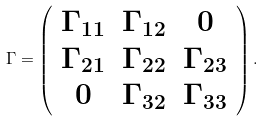<formula> <loc_0><loc_0><loc_500><loc_500>\Gamma = \left ( \begin{array} { c c c } \Gamma _ { 1 1 } & \Gamma _ { 1 2 } & 0 \\ \Gamma _ { 2 1 } & \Gamma _ { 2 2 } & \Gamma _ { 2 3 } \\ 0 & \Gamma _ { 3 2 } & \Gamma _ { 3 3 } \end{array} \right ) .</formula> 